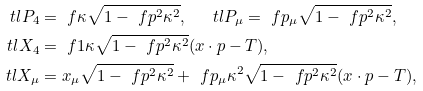Convert formula to latex. <formula><loc_0><loc_0><loc_500><loc_500>\ t l { P } _ { 4 } & = \ f { \kappa } { \sqrt { 1 - \ f { p ^ { 2 } } { \kappa ^ { 2 } } } } , \quad \, \ t l { P } _ { \mu } = \ f { p _ { \mu } } { \sqrt { 1 - \ f { p ^ { 2 } } { \kappa ^ { 2 } } } } , \\ \ t l { X } _ { 4 } & = \ f { 1 } { \kappa \sqrt { 1 - \ f { p ^ { 2 } } { \kappa ^ { 2 } } } } ( x \cdot p - T ) , \\ \ t l { X } _ { \mu } & = x _ { \mu } \sqrt { 1 - \ f { p ^ { 2 } } { \kappa ^ { 2 } } } + \ f { p _ { \mu } } { \kappa ^ { 2 } \sqrt { 1 - \ f { p ^ { 2 } } { \kappa ^ { 2 } } } } ( x \cdot p - T ) ,</formula> 